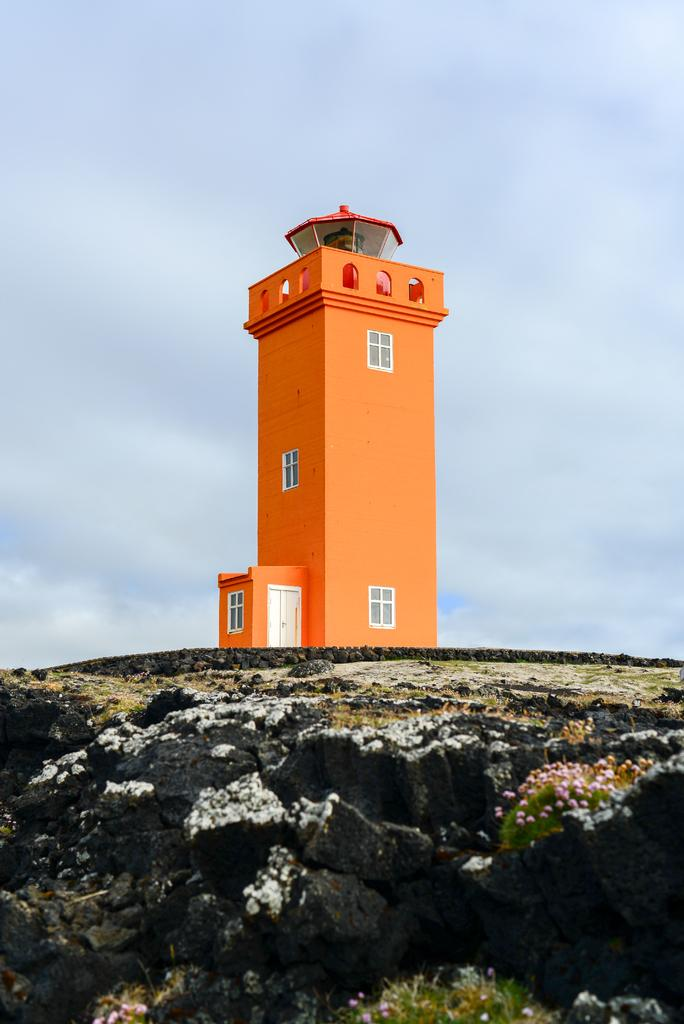What type of structure is in the image? There is a building in the image. What features can be seen on the building? The building has windows and a door. What type of natural environment is visible in the image? There is grass visible in the image. What is visible in the sky in the image? The sky is visible in the image, and clouds are present. What type of jelly is being used to hold the books in the image? There is no jelly or books present in the image; it only features a building, grass, and the sky with clouds. 